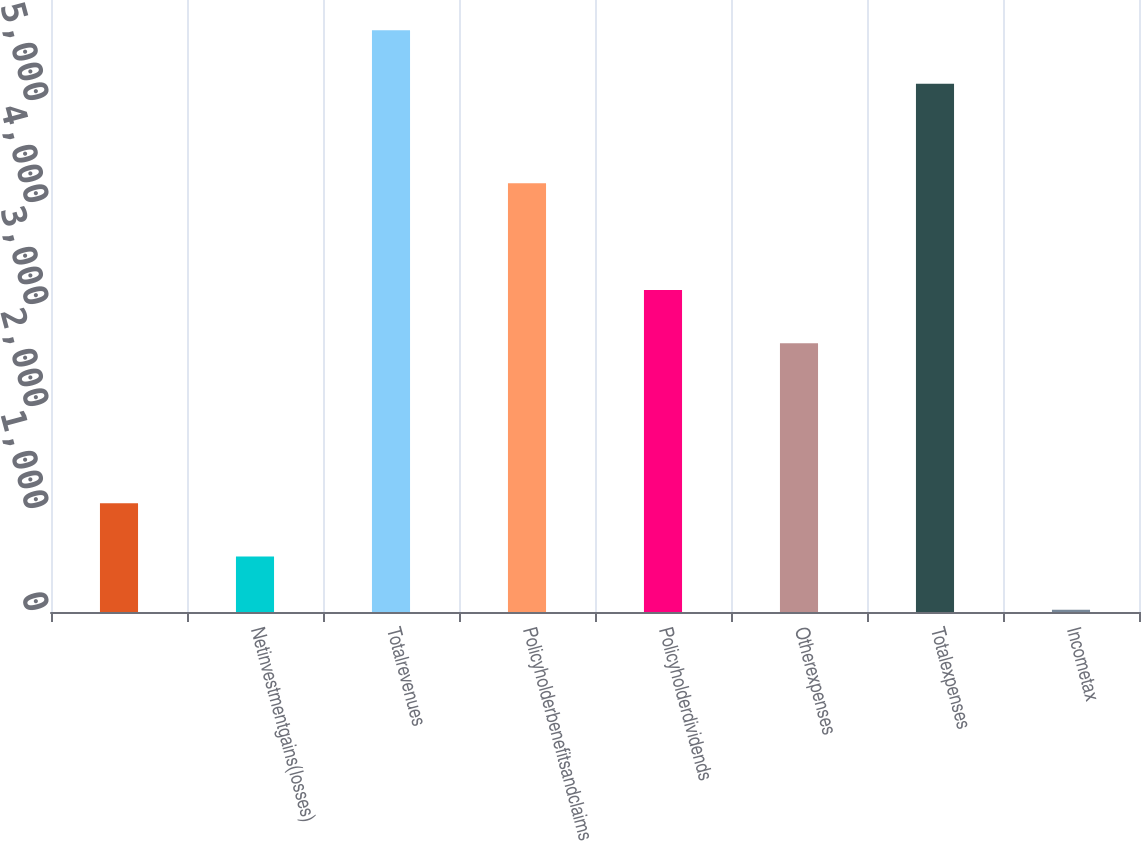Convert chart. <chart><loc_0><loc_0><loc_500><loc_500><bar_chart><ecel><fcel>Netinvestmentgains(losses)<fcel>Totalrevenues<fcel>Policyholderbenefitsandclaims<fcel>Policyholderdividends<fcel>Otherexpenses<fcel>Totalexpenses<fcel>Incometax<nl><fcel>1066.4<fcel>543.7<fcel>5702.7<fcel>4202.6<fcel>3157.2<fcel>2634.5<fcel>5180<fcel>21<nl></chart> 